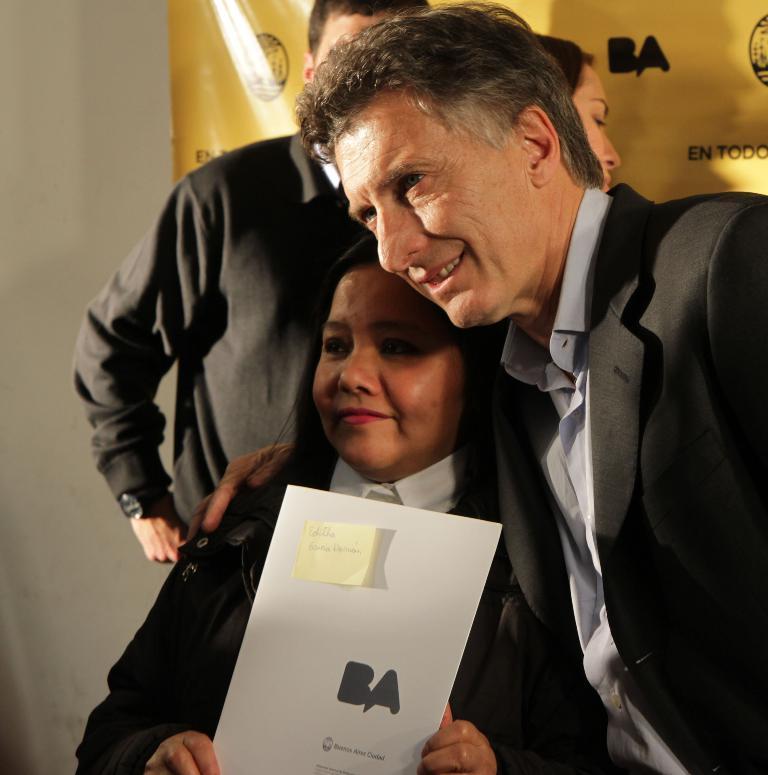In one or two sentences, can you explain what this image depicts? In this picture we can observe a man and a woman. The woman is holding a white color board in her hand and smiling. The man is wearing black color coat. In the background there are two members standing. We can observe yellow color poster. On the left side there is a wall. 